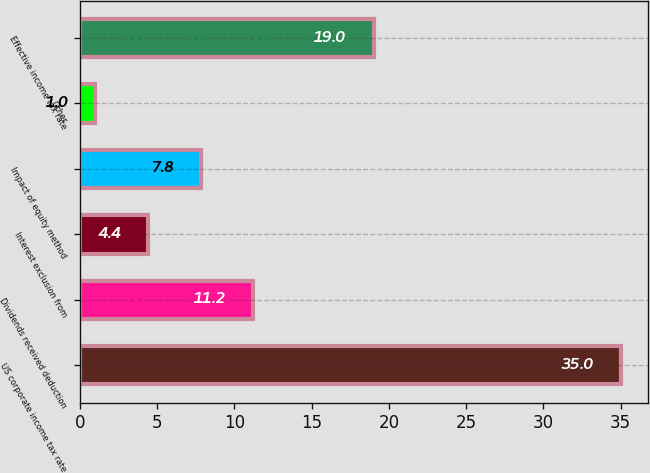Convert chart. <chart><loc_0><loc_0><loc_500><loc_500><bar_chart><fcel>US corporate income tax rate<fcel>Dividends received deduction<fcel>Interest exclusion from<fcel>Impact of equity method<fcel>Other<fcel>Effective income tax rate<nl><fcel>35<fcel>11.2<fcel>4.4<fcel>7.8<fcel>1<fcel>19<nl></chart> 